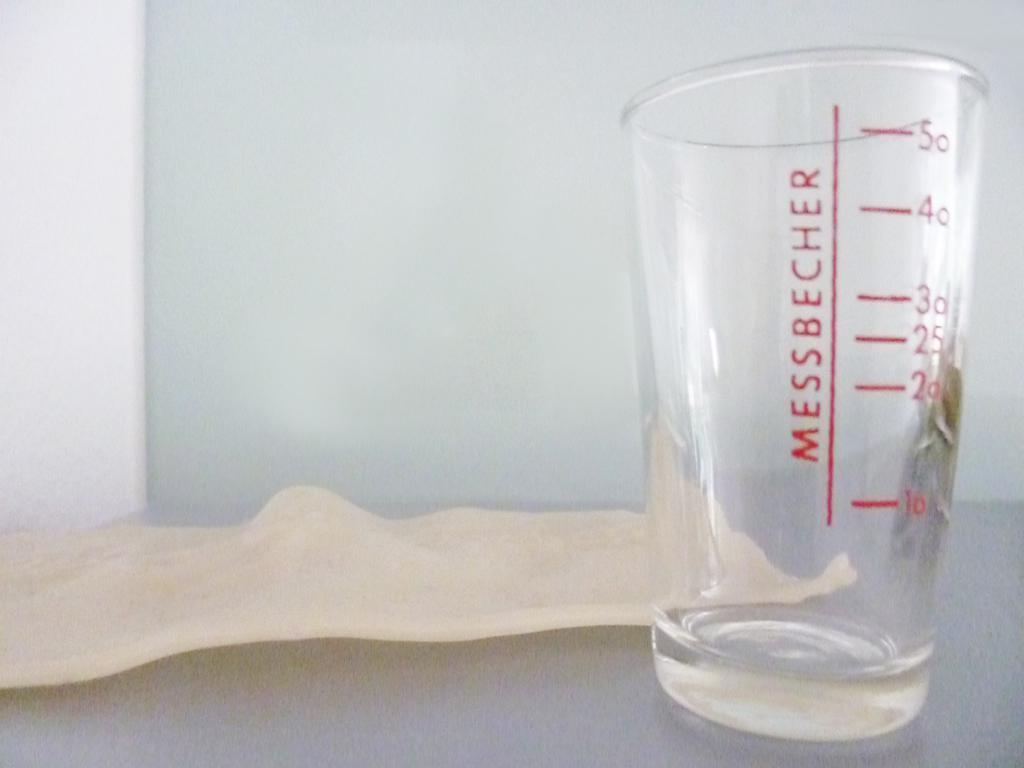Provide a one-sentence caption for the provided image. A cup with the measurements 10, 20, 35, 30, 40 and 50. 